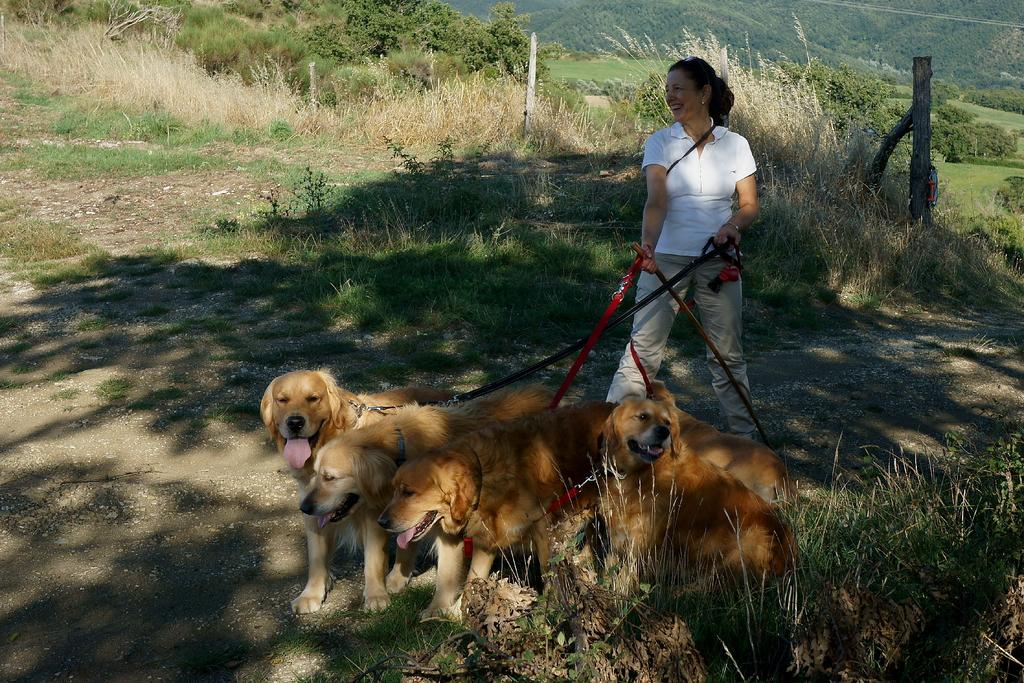Who is present in the image? There is a woman in the image. What is the woman wearing? The woman is wearing a white t-shirt. What is the woman doing in the image? The woman is standing on the ground. What is the woman holding in the image? The woman is holding four brown dog leashes. What can be seen in the background of the image? There is grass and trees visible in the background of the image. What type of curtain can be seen blowing in the wind in the image? There is no curtain present in the image; it features a woman holding dog leashes and standing on grass with trees in the background. How many kites are visible in the image? There are no kites present in the image. 